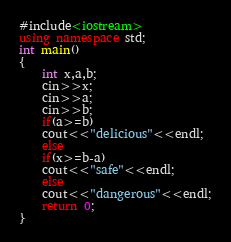Convert code to text. <code><loc_0><loc_0><loc_500><loc_500><_C++_>#include<iostream>
using namespace std;
int main()
{
	int x,a,b;
	cin>>x;
	cin>>a;
	cin>>b;
	if(a>=b)
	cout<<"delicious"<<endl;
	else
	if(x>=b-a)
	cout<<"safe"<<endl;
	else
	cout<<"dangerous"<<endl;
	return 0;
} </code> 